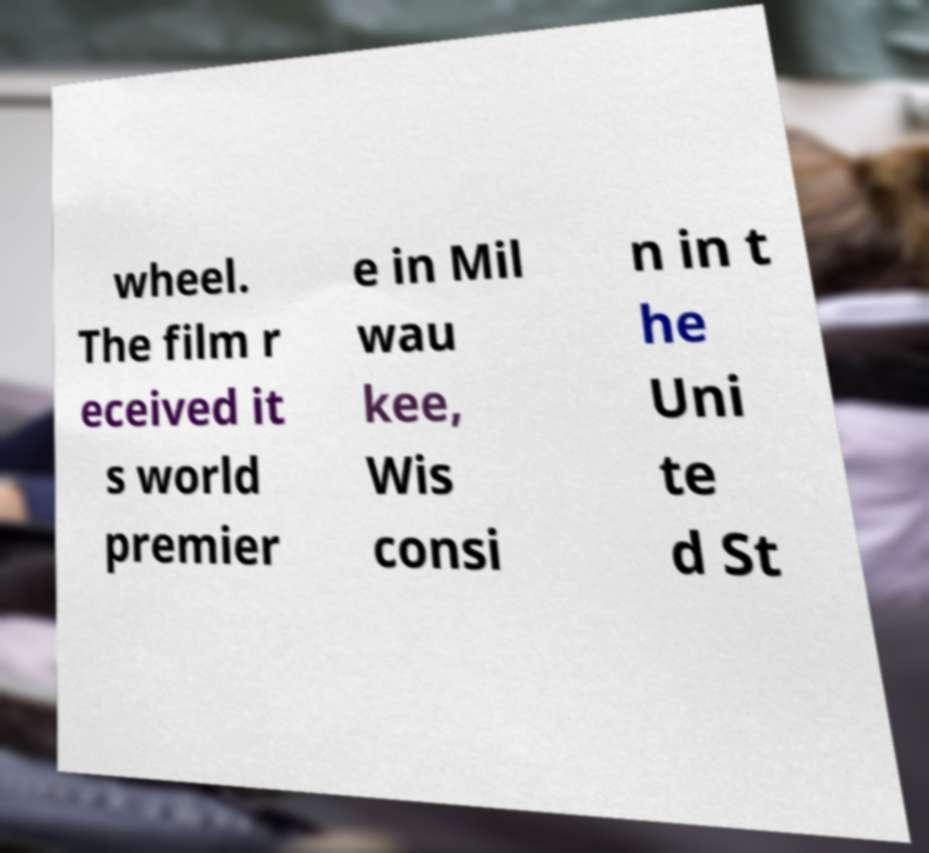There's text embedded in this image that I need extracted. Can you transcribe it verbatim? wheel. The film r eceived it s world premier e in Mil wau kee, Wis consi n in t he Uni te d St 